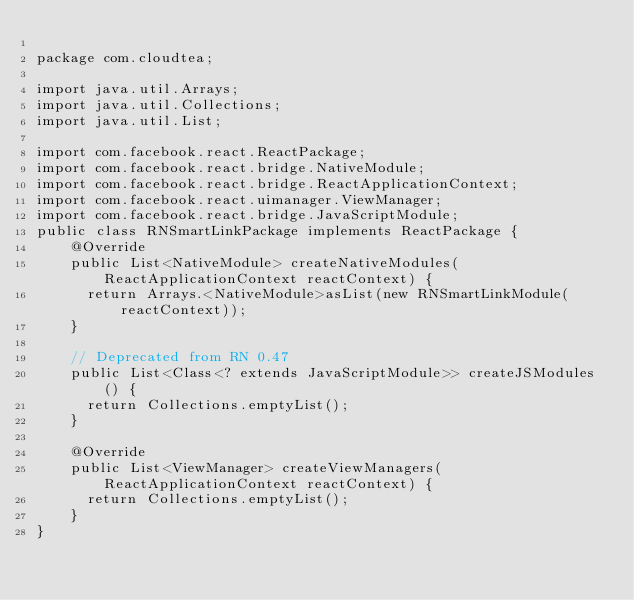<code> <loc_0><loc_0><loc_500><loc_500><_Java_>
package com.cloudtea;

import java.util.Arrays;
import java.util.Collections;
import java.util.List;

import com.facebook.react.ReactPackage;
import com.facebook.react.bridge.NativeModule;
import com.facebook.react.bridge.ReactApplicationContext;
import com.facebook.react.uimanager.ViewManager;
import com.facebook.react.bridge.JavaScriptModule;
public class RNSmartLinkPackage implements ReactPackage {
    @Override
    public List<NativeModule> createNativeModules(ReactApplicationContext reactContext) {
      return Arrays.<NativeModule>asList(new RNSmartLinkModule(reactContext));
    }

    // Deprecated from RN 0.47
    public List<Class<? extends JavaScriptModule>> createJSModules() {
      return Collections.emptyList();
    }

    @Override
    public List<ViewManager> createViewManagers(ReactApplicationContext reactContext) {
      return Collections.emptyList();
    }
}</code> 